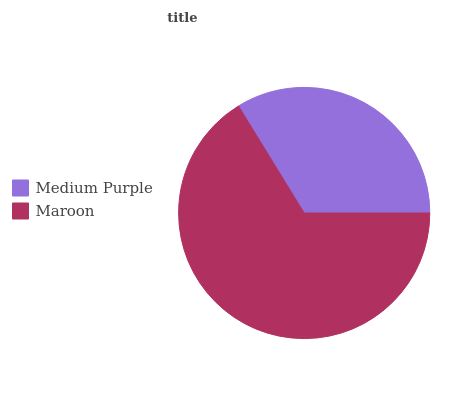Is Medium Purple the minimum?
Answer yes or no. Yes. Is Maroon the maximum?
Answer yes or no. Yes. Is Maroon the minimum?
Answer yes or no. No. Is Maroon greater than Medium Purple?
Answer yes or no. Yes. Is Medium Purple less than Maroon?
Answer yes or no. Yes. Is Medium Purple greater than Maroon?
Answer yes or no. No. Is Maroon less than Medium Purple?
Answer yes or no. No. Is Maroon the high median?
Answer yes or no. Yes. Is Medium Purple the low median?
Answer yes or no. Yes. Is Medium Purple the high median?
Answer yes or no. No. Is Maroon the low median?
Answer yes or no. No. 